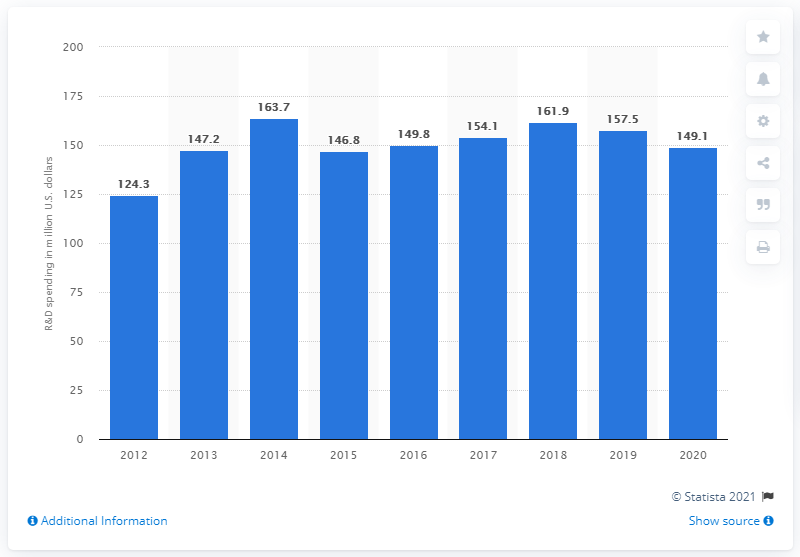Draw attention to some important aspects in this diagram. The R&D spending of Qiagen in the United States in 2020 was 149.1 million dollars. 